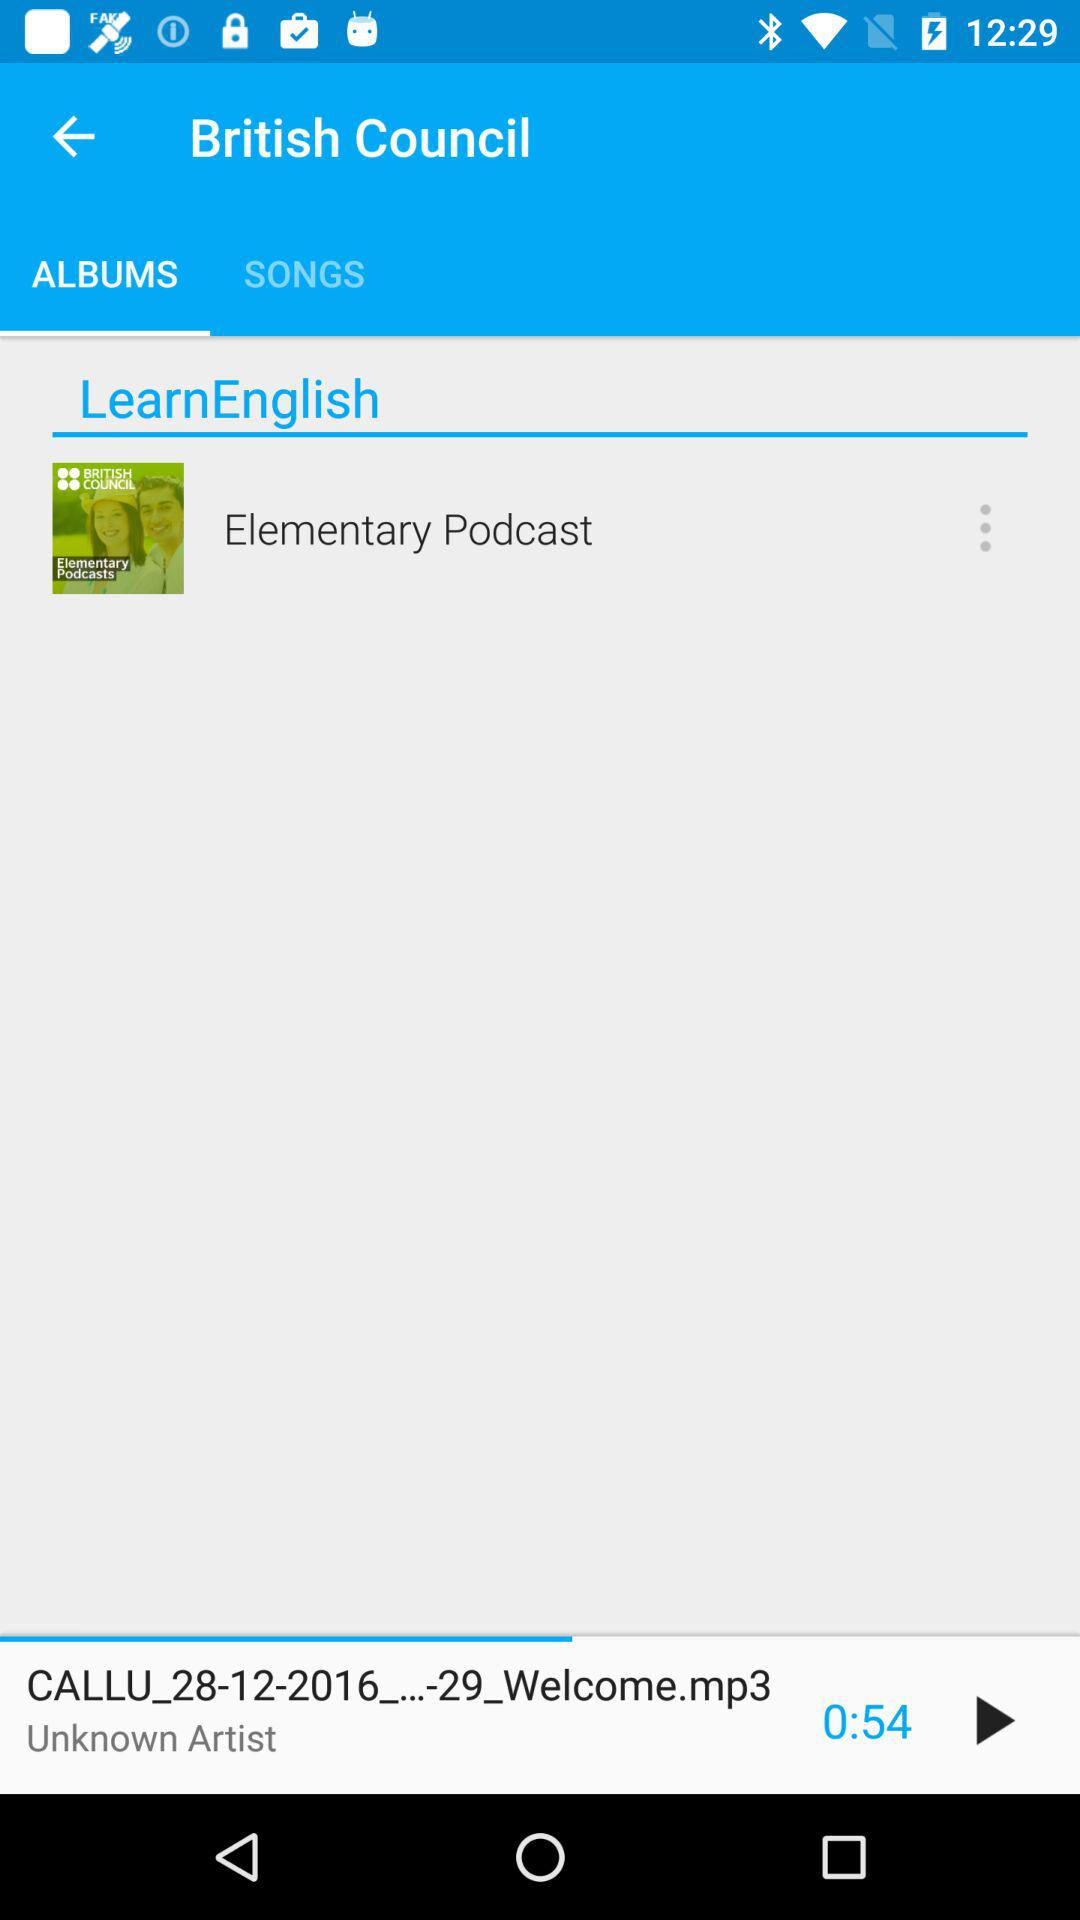What is the duration of the song? The duration of the song is 54 seconds. 